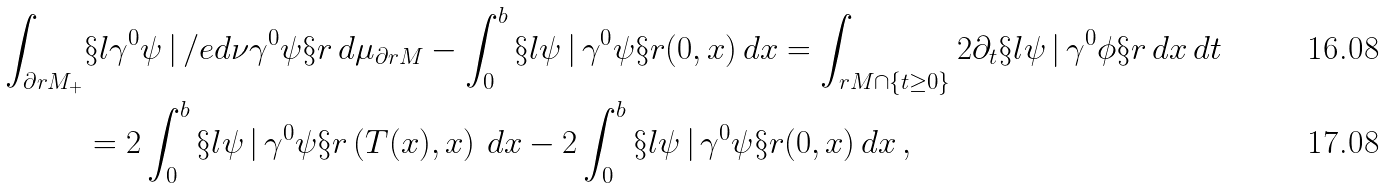<formula> <loc_0><loc_0><loc_500><loc_500>\int _ { \partial r M _ { + } } & \S l \gamma ^ { 0 } \psi \, | \, \slash e d { \nu } \gamma ^ { 0 } \psi \S r \, d \mu _ { \partial r M } - \int _ { 0 } ^ { b } \S l \psi \, | \, \gamma ^ { 0 } \psi \S r ( 0 , x ) \, d x = \int _ { r M \cap \{ t \geq 0 \} } 2 \partial _ { t } \S l \psi \, | \, \gamma ^ { 0 } \phi \S r \, d x \, d t \\ & = 2 \int _ { 0 } ^ { b } \S l \psi \, | \, \gamma ^ { 0 } \psi \S r \left ( T ( x ) , x \right ) \, d x - 2 \int _ { 0 } ^ { b } \S l \psi \, | \, \gamma ^ { 0 } \psi \S r ( 0 , x ) \, d x \, ,</formula> 